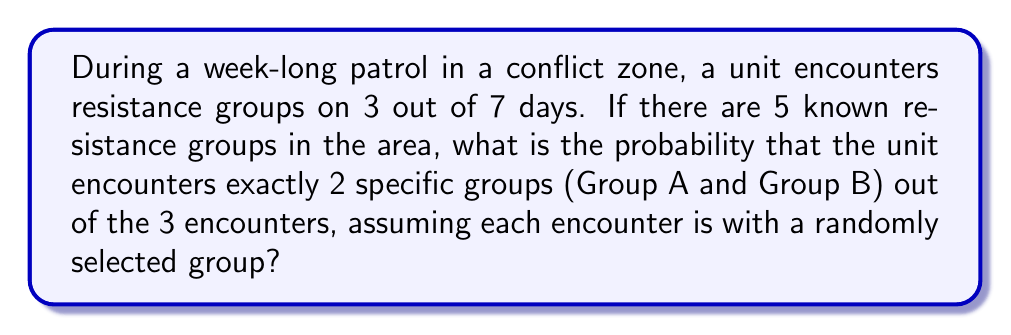Can you solve this math problem? Let's approach this step-by-step:

1) First, we need to calculate the total number of possible ways to encounter 3 groups out of 5. This is a combination problem:

   $$\binom{5}{3} = \frac{5!}{3!(5-3)!} = \frac{5!}{3!2!} = 10$$

2) Now, we need to calculate the number of ways to encounter exactly Group A and Group B in 2 out of the 3 encounters, and any other group in the third encounter. This can be broken down:

   - Choose 2 positions for Groups A and B out of 3: $\binom{3}{2} = 3$
   - Arrange A and B in these 2 positions: $2! = 2$
   - Choose 1 group from the remaining 3 groups for the third position: $\binom{3}{1} = 3$

3) Multiply these together:

   $$3 \times 2 \times 3 = 18$$

4) The probability is then the number of favorable outcomes divided by the total number of possible outcomes:

   $$P(\text{exactly A and B in 2 out of 3 encounters}) = \frac{18}{10 \times 10 \times 10} = \frac{18}{1000} = \frac{9}{500}$$

   We multiply by $10 \times 10 \times 10$ in the denominator because for each of the 3 encounters, there are 10 possible group combinations.
Answer: $\frac{9}{500}$ or $0.018$ or $1.8\%$ 